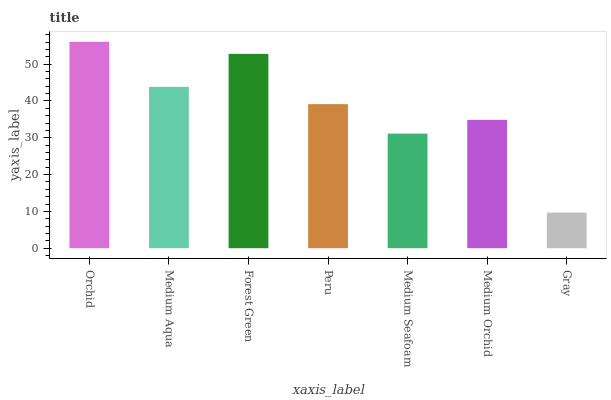Is Gray the minimum?
Answer yes or no. Yes. Is Orchid the maximum?
Answer yes or no. Yes. Is Medium Aqua the minimum?
Answer yes or no. No. Is Medium Aqua the maximum?
Answer yes or no. No. Is Orchid greater than Medium Aqua?
Answer yes or no. Yes. Is Medium Aqua less than Orchid?
Answer yes or no. Yes. Is Medium Aqua greater than Orchid?
Answer yes or no. No. Is Orchid less than Medium Aqua?
Answer yes or no. No. Is Peru the high median?
Answer yes or no. Yes. Is Peru the low median?
Answer yes or no. Yes. Is Medium Aqua the high median?
Answer yes or no. No. Is Medium Aqua the low median?
Answer yes or no. No. 